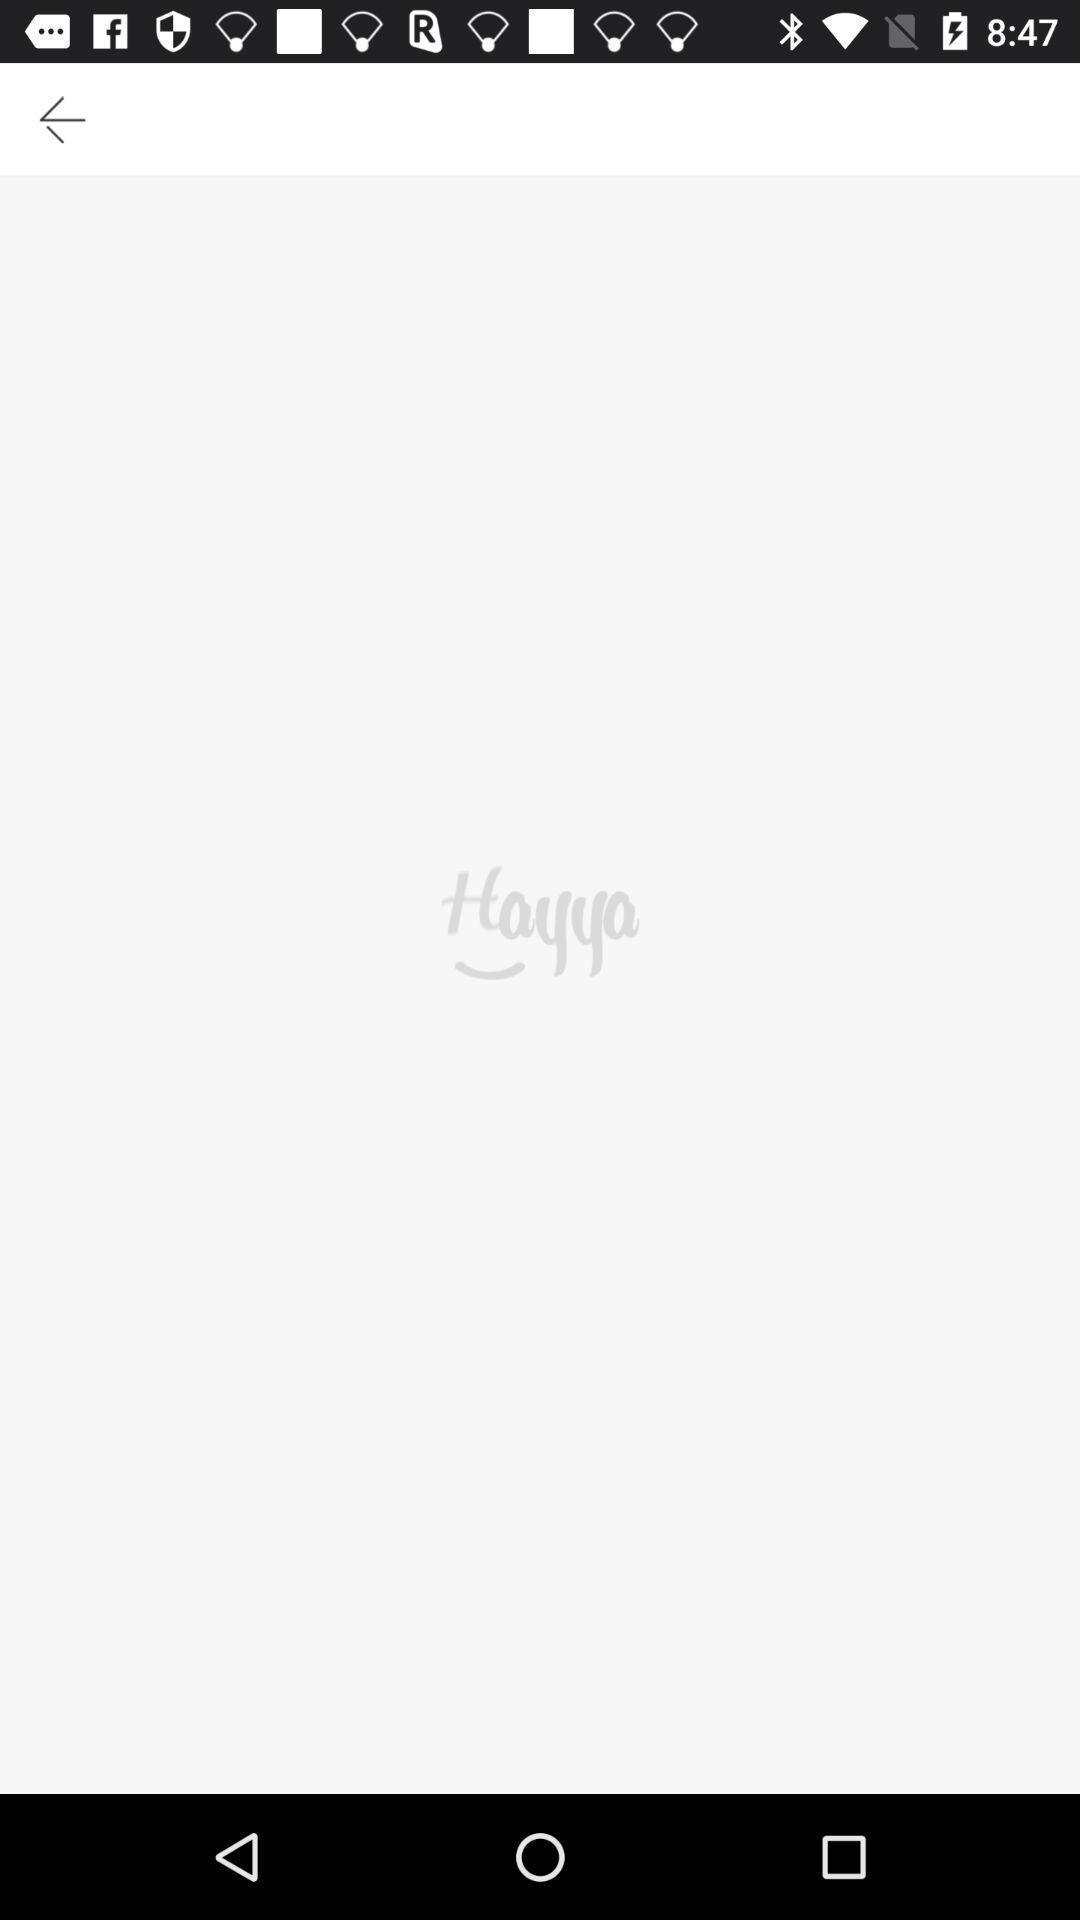Give me a narrative description of this picture. Screen shows blank page. 